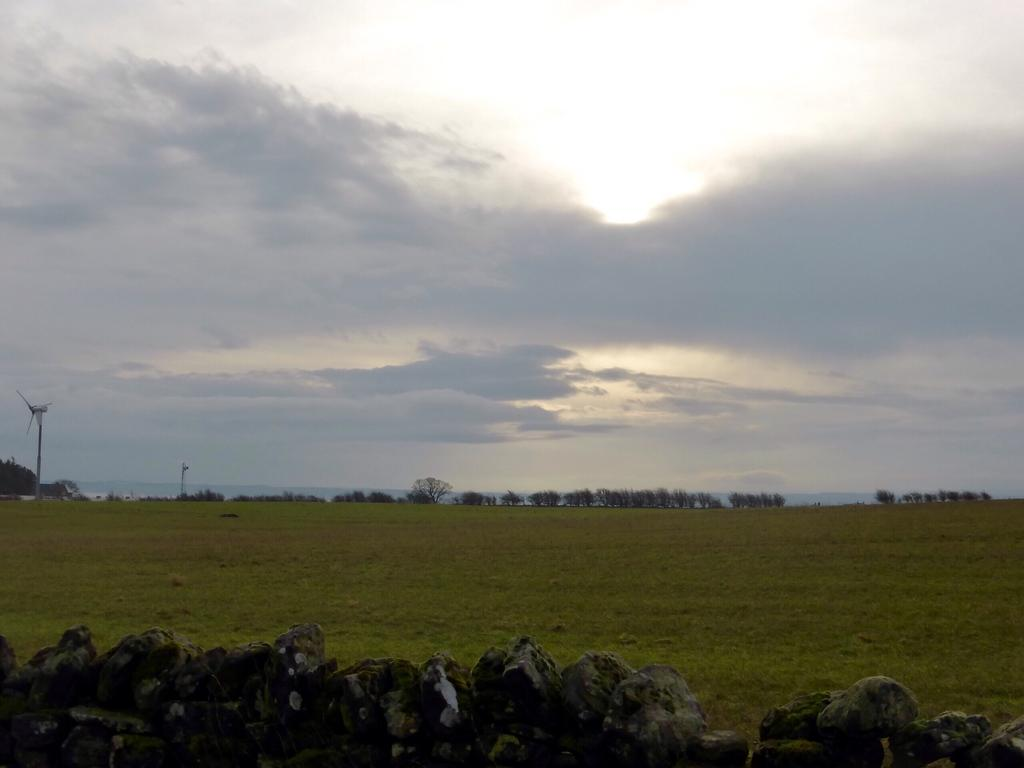What type of vegetation can be seen in the image? There is grass in the image. What other natural elements are present in the image? There are rocks and trees in the image. How would you describe the sky in the image? The sky is cloudy in the image. Can you see a worm crawling on the grass in the image? There is no worm present in the image; it only features grass, rocks, trees, and a cloudy sky. 